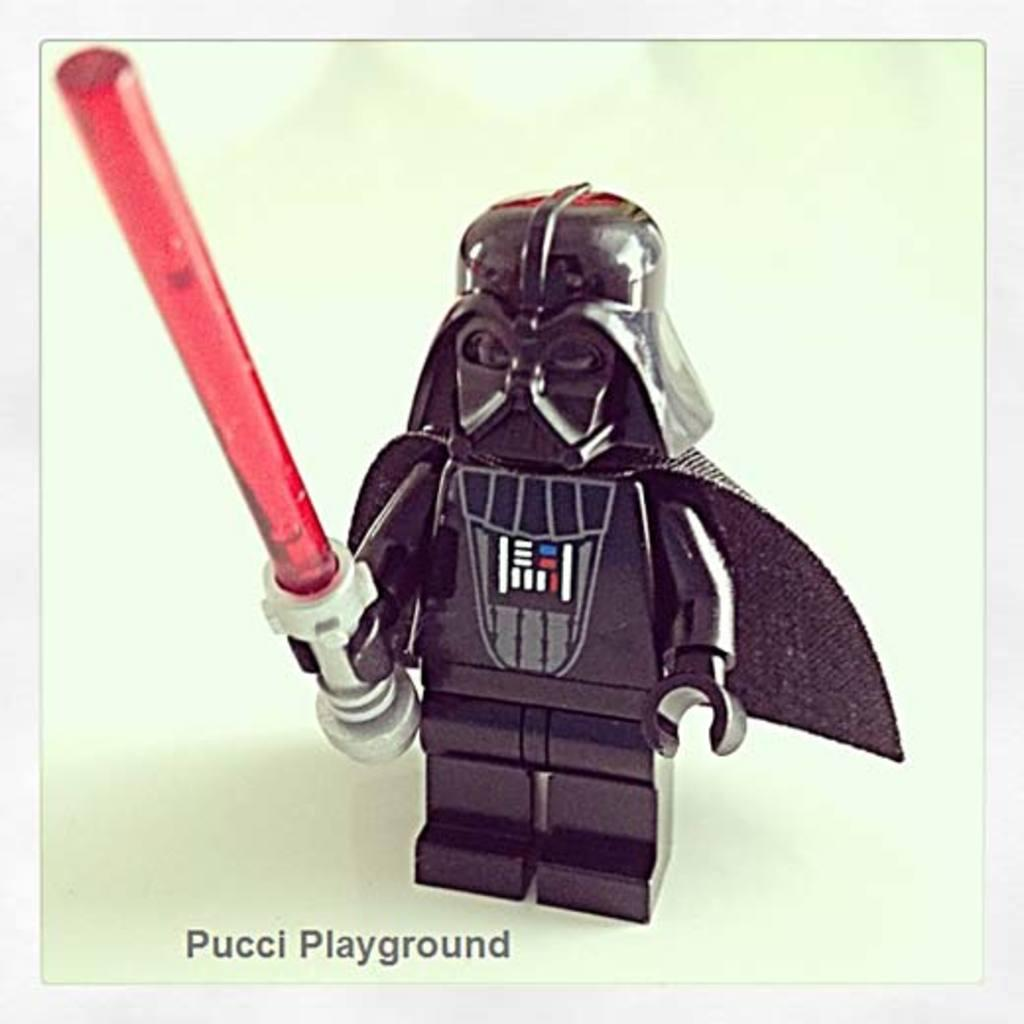What object can be seen in the image? There is a toy in the image. What color is the background of the image? The background of the image is white. Is there any text present in the image? Yes, there is text at the bottom of the image. Can you see any boats in the harbor in the image? There is no harbor or boats present in the image; it features a toy and a white background with text at the bottom. 